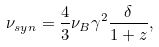<formula> <loc_0><loc_0><loc_500><loc_500>\nu _ { s y n } = \frac { 4 } { 3 } \nu _ { B } \gamma ^ { 2 } \frac { \delta } { 1 + z } ,</formula> 